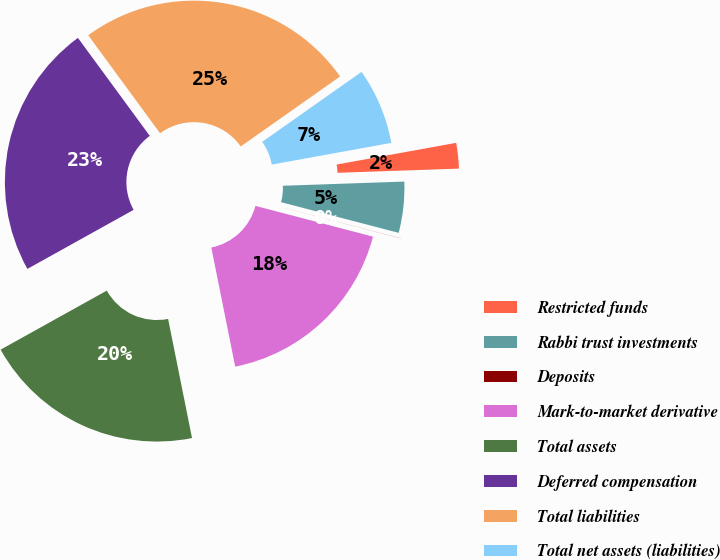<chart> <loc_0><loc_0><loc_500><loc_500><pie_chart><fcel>Restricted funds<fcel>Rabbi trust investments<fcel>Deposits<fcel>Mark-to-market derivative<fcel>Total assets<fcel>Deferred compensation<fcel>Total liabilities<fcel>Total net assets (liabilities)<nl><fcel>2.31%<fcel>4.61%<fcel>0.01%<fcel>17.78%<fcel>20.08%<fcel>23.01%<fcel>25.31%<fcel>6.91%<nl></chart> 